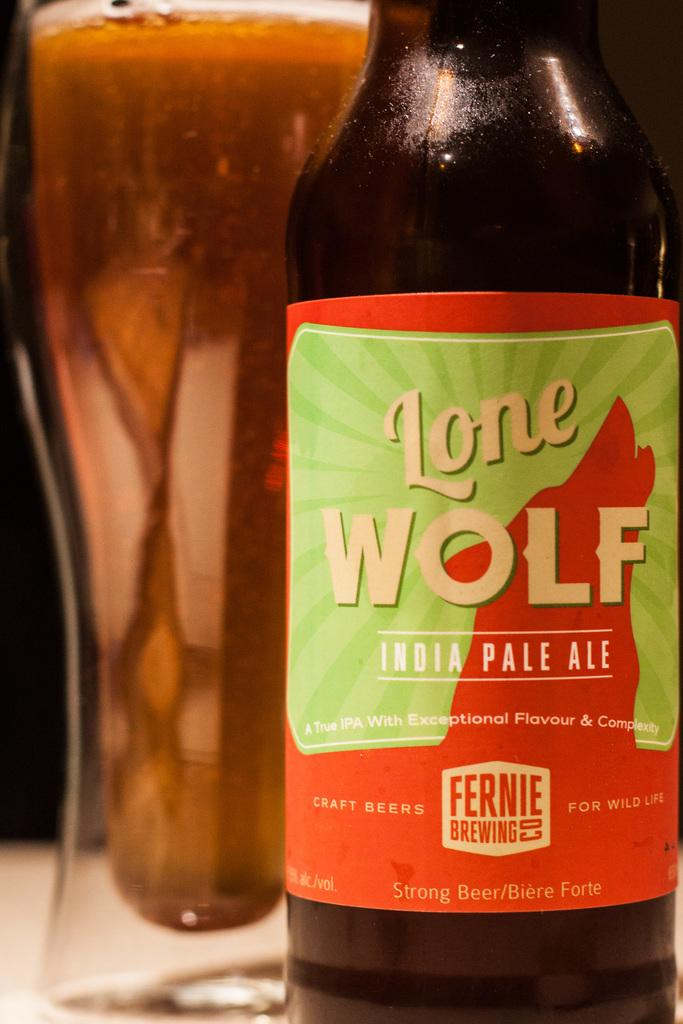What object can be seen in the image with a paper attached to it? There is a bottle in the image with a paper attached to it. What is written or depicted on the paper? There is text on the paper. What is located on the left side of the image? There is a glass on the left side of the image. What is inside the glass? The glass contains a drink. How many clocks are visible in the image? There are no clocks present in the image. What type of crowd can be seen gathering around the bottle in the image? There is no crowd present in the image; it only features a bottle with a paper attached to it and a glass with a drink. 